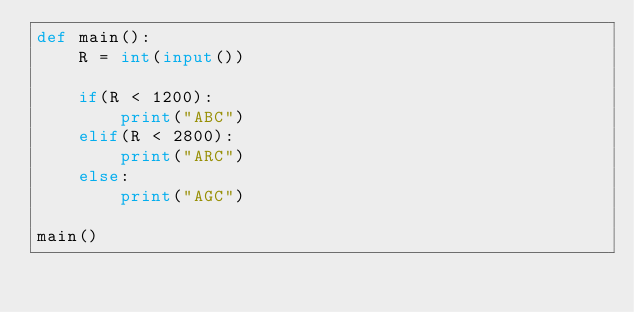<code> <loc_0><loc_0><loc_500><loc_500><_Python_>def main():
    R = int(input())

    if(R < 1200):
        print("ABC")
    elif(R < 2800):
        print("ARC")
    else:
        print("AGC")

main()</code> 